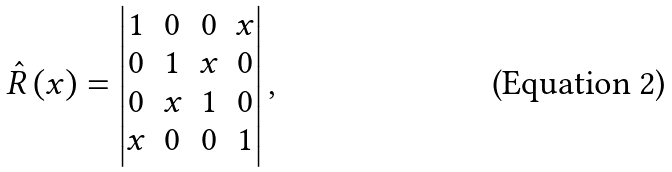Convert formula to latex. <formula><loc_0><loc_0><loc_500><loc_500>\hat { R } \left ( x \right ) = \begin{vmatrix} 1 & 0 & 0 & x \\ 0 & 1 & x & 0 \\ 0 & x & 1 & 0 \\ x & 0 & 0 & 1 \\ \end{vmatrix} ,</formula> 